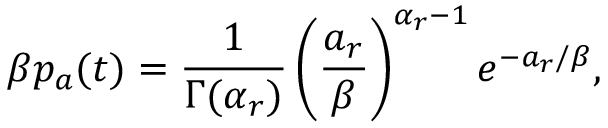<formula> <loc_0><loc_0><loc_500><loc_500>\beta p _ { a } ( t ) = \frac { 1 } { \Gamma ( \alpha _ { r } ) } \left ( \frac { a _ { r } } { \beta } \right ) ^ { \alpha _ { r } - 1 } e ^ { - a _ { r } / \beta } ,</formula> 